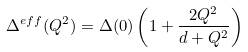Convert formula to latex. <formula><loc_0><loc_0><loc_500><loc_500>\Delta ^ { e f f } ( Q ^ { 2 } ) = \Delta ( 0 ) \left ( 1 + \frac { 2 Q ^ { 2 } } { d + Q ^ { 2 } } \right )</formula> 